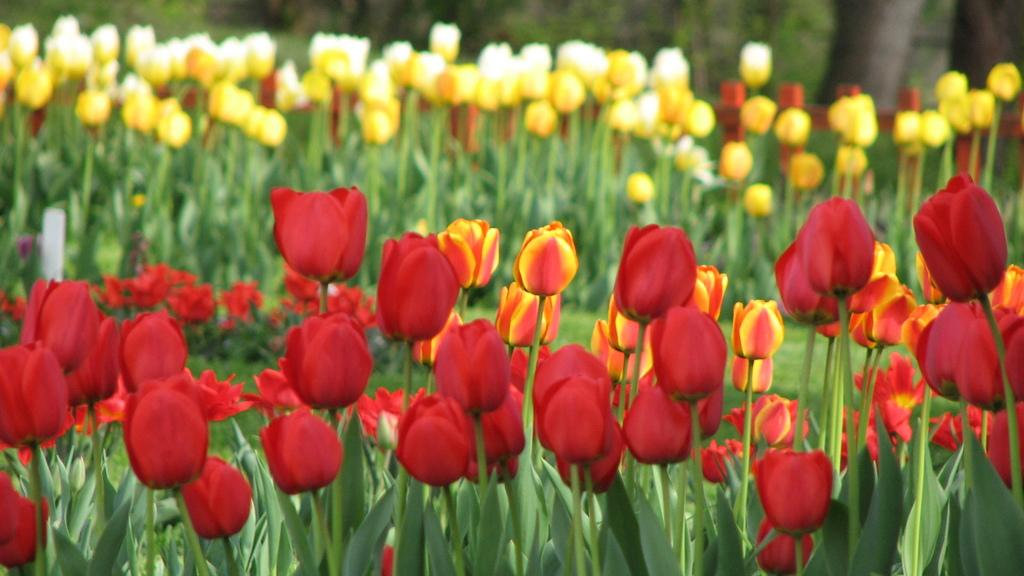What type of flowers can be seen at the bottom of the image? There are red color flowers at the bottom of the image. What color are the flowers in the background of the image? There are yellow color flowers in the background of the image. What is the common feature among the plants in the image? The plants in the image have flowers on them. Where is the volleyball court located in the image? There is no volleyball court present in the image. What type of amusement can be seen in the image? There is no amusement depicted in the image; it features flowers and plants. 